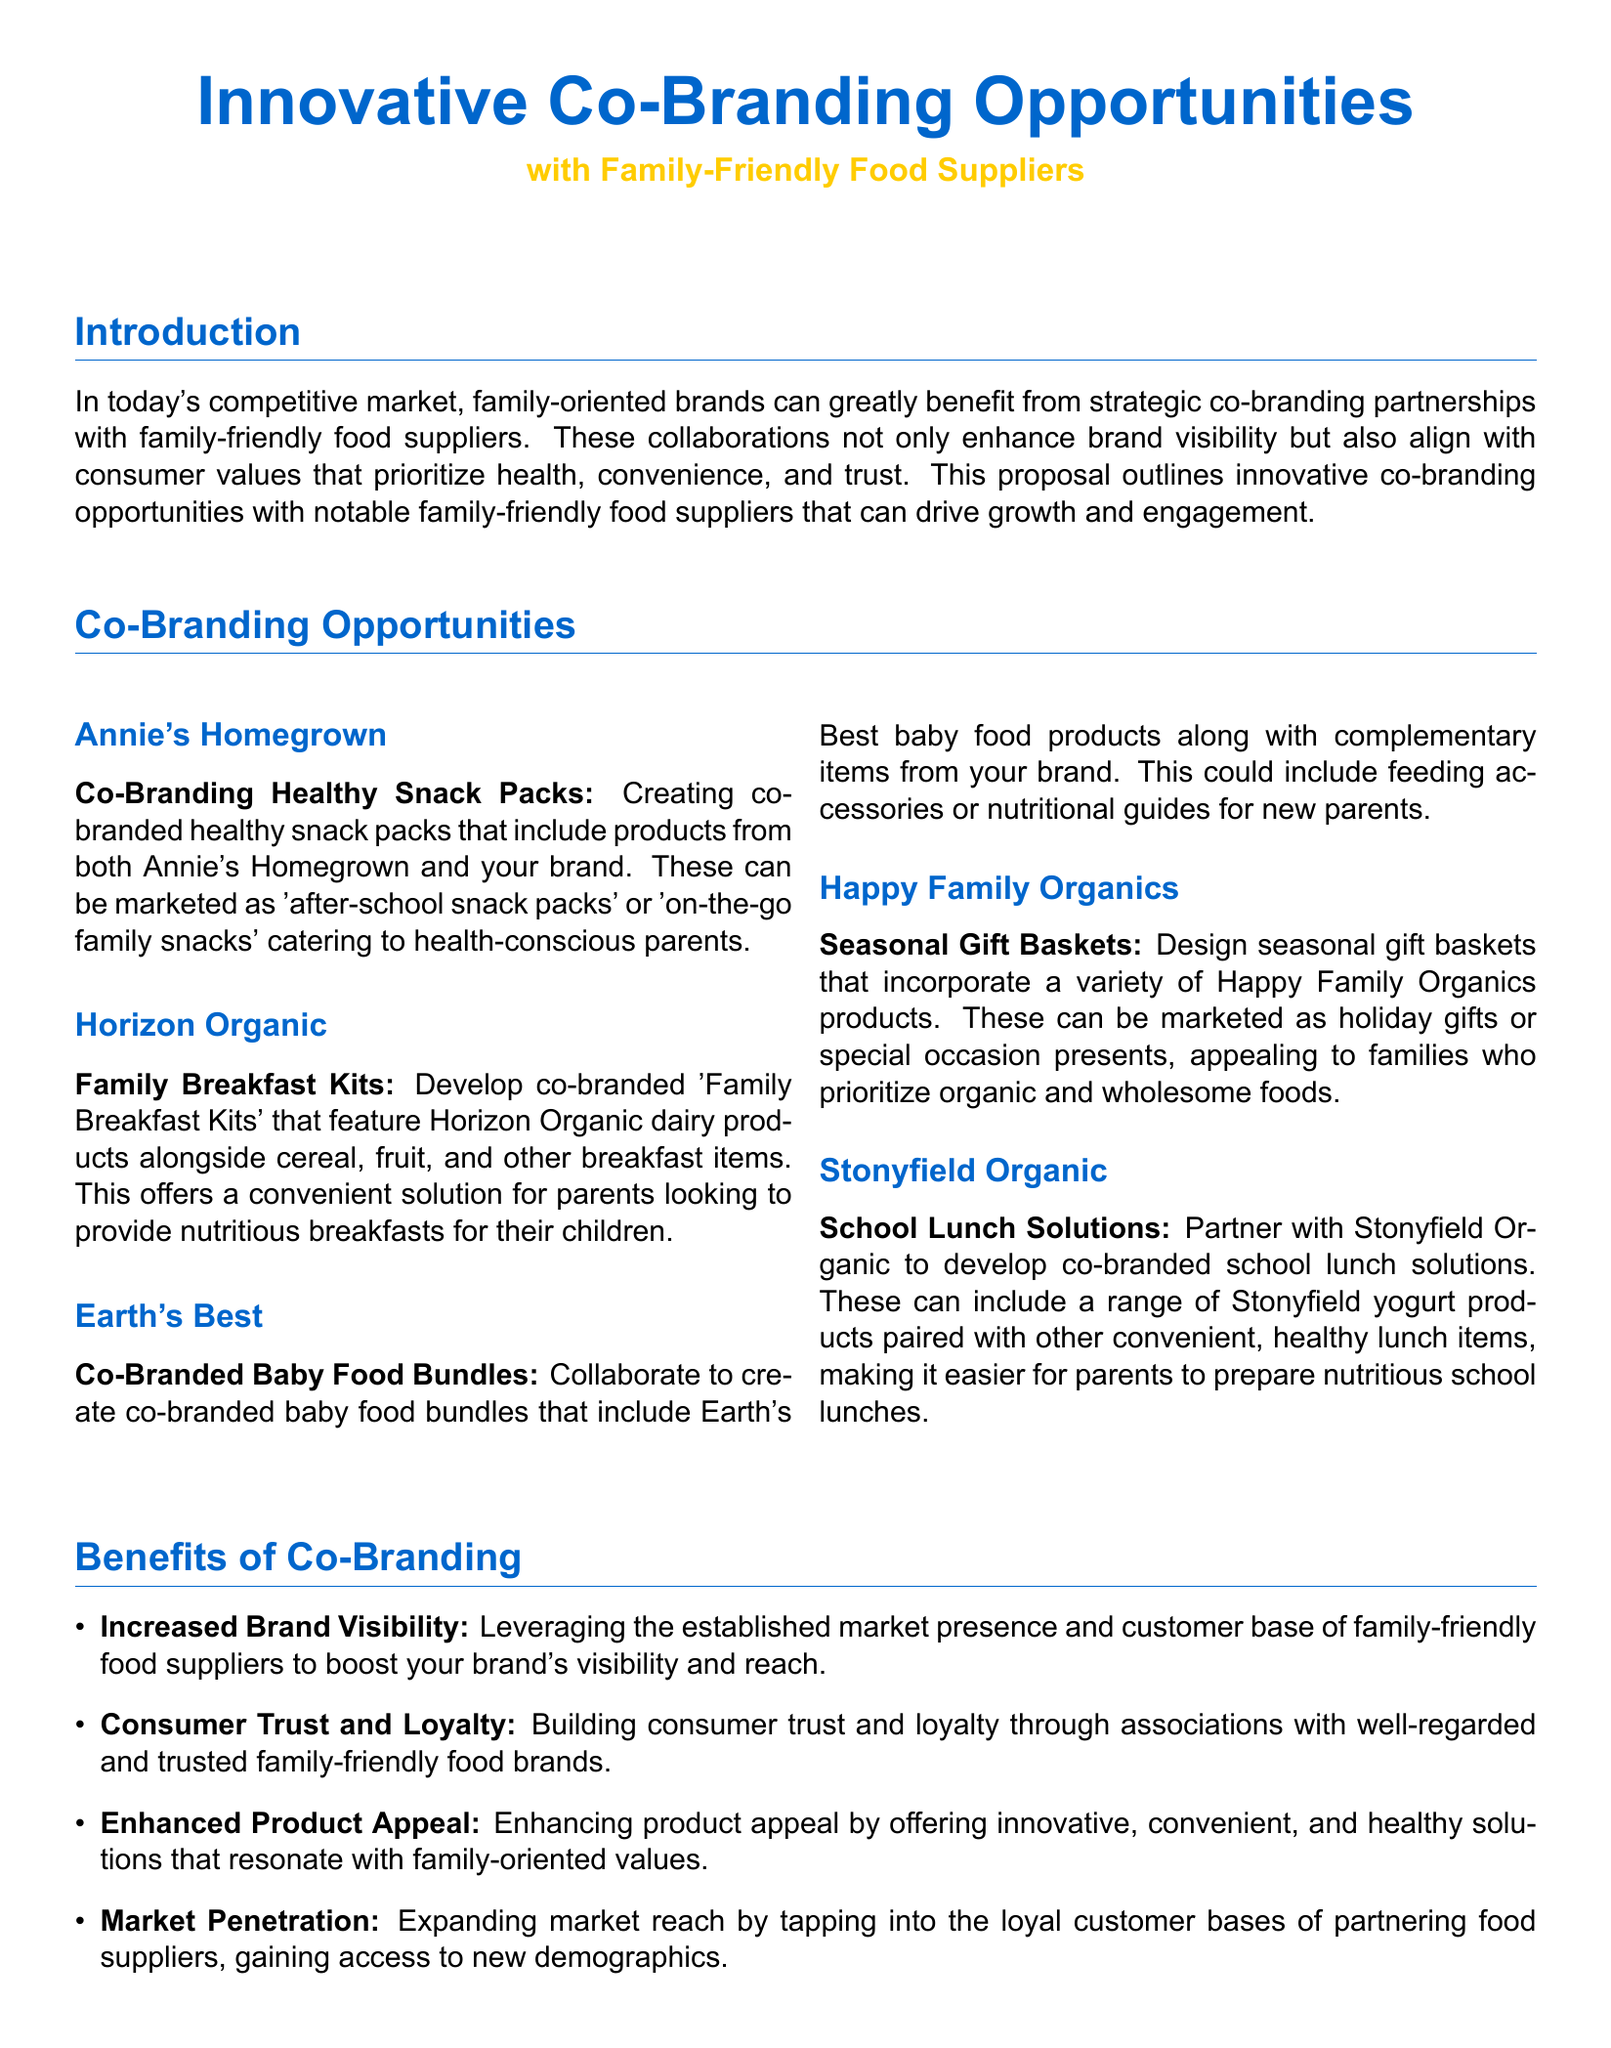What is the title of the proposal? The title of the proposal is prominently displayed at the top of the document.
Answer: Innovative Co-Branding Opportunities with Family-Friendly Food Suppliers Who is the first food supplier mentioned in the co-branding opportunities? The first food supplier listed under co-branding opportunities is Annie's Homegrown.
Answer: Annie's Homegrown What product category is proposed for collaboration with Horizon Organic? This question looks for the specific product category mentioned in the co-branding opportunity with Horizon Organic.
Answer: Family Breakfast Kits What is a proposed benefit of co-branding mentioned in the document? The document lists several benefits, showcasing increased brand visibility as one of them.
Answer: Increased Brand Visibility How many co-branding opportunities are listed in the document? To determine the total number of co-branding opportunities, you need to count the items presented.
Answer: Five 